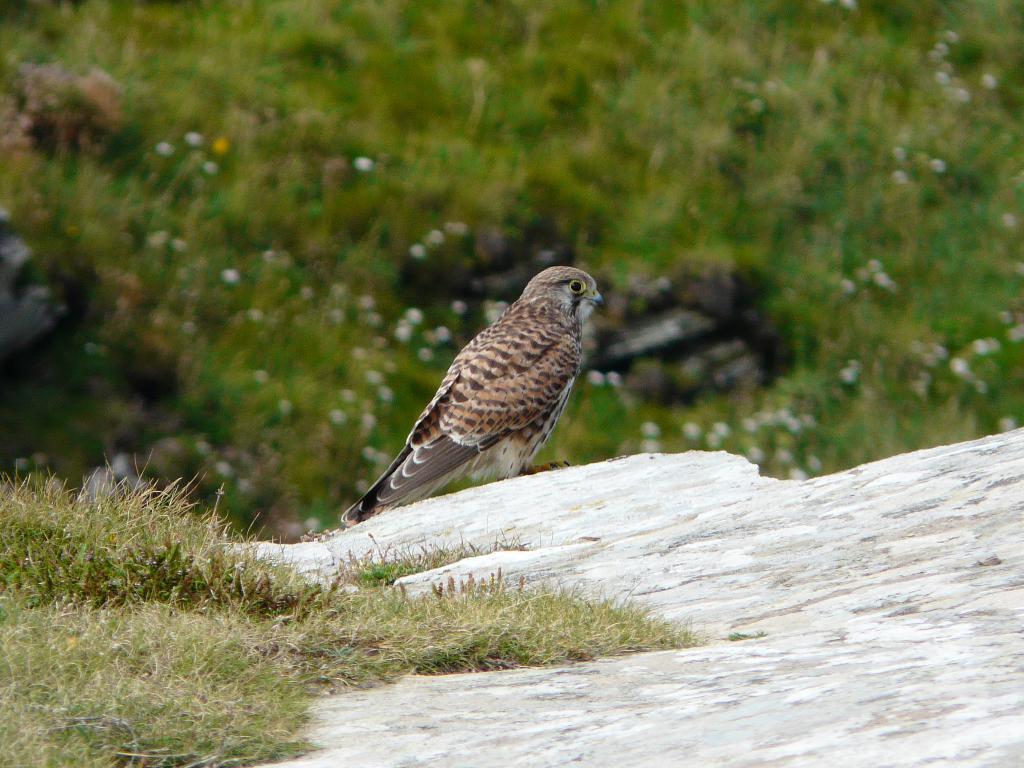Please provide a concise description of this image. In the middle of the image, there is a bird on an edge of a ground, on which there is grass. In the background, there are plants having flowers and there's grass on the ground of a hill. 